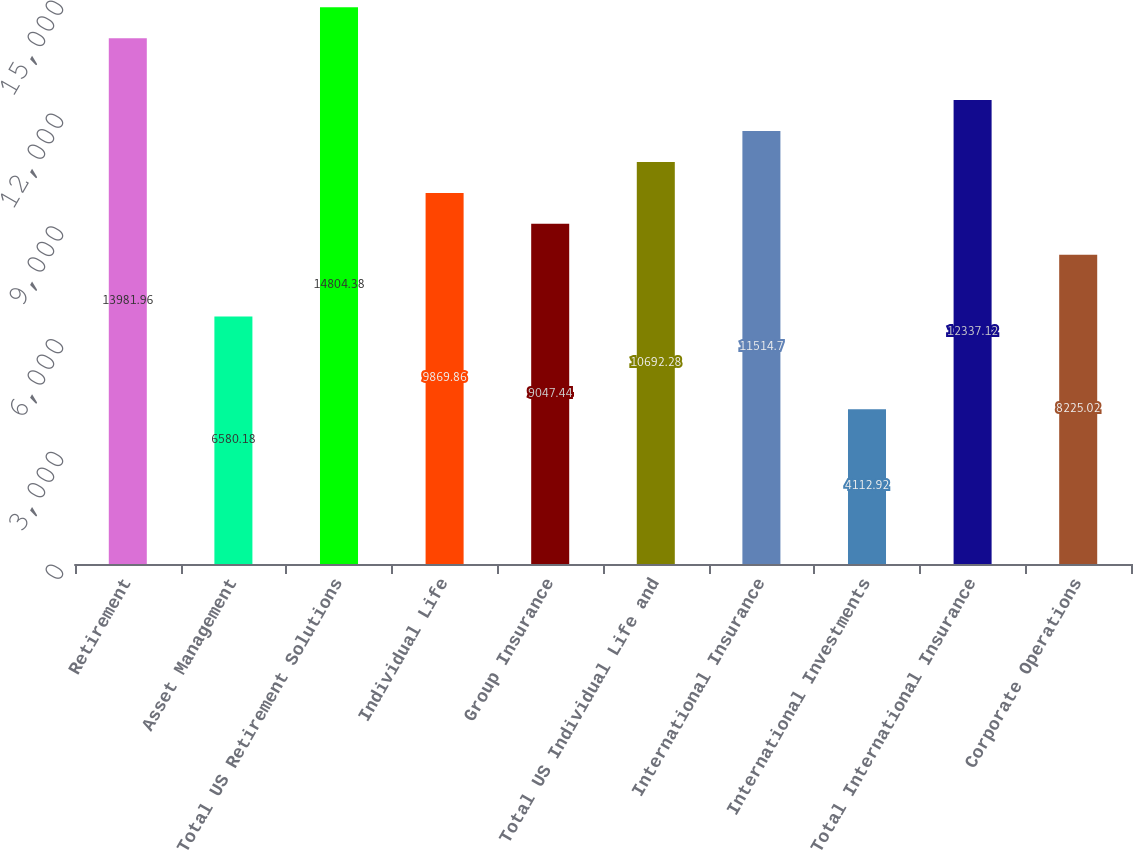Convert chart. <chart><loc_0><loc_0><loc_500><loc_500><bar_chart><fcel>Retirement<fcel>Asset Management<fcel>Total US Retirement Solutions<fcel>Individual Life<fcel>Group Insurance<fcel>Total US Individual Life and<fcel>International Insurance<fcel>International Investments<fcel>Total International Insurance<fcel>Corporate Operations<nl><fcel>13982<fcel>6580.18<fcel>14804.4<fcel>9869.86<fcel>9047.44<fcel>10692.3<fcel>11514.7<fcel>4112.92<fcel>12337.1<fcel>8225.02<nl></chart> 